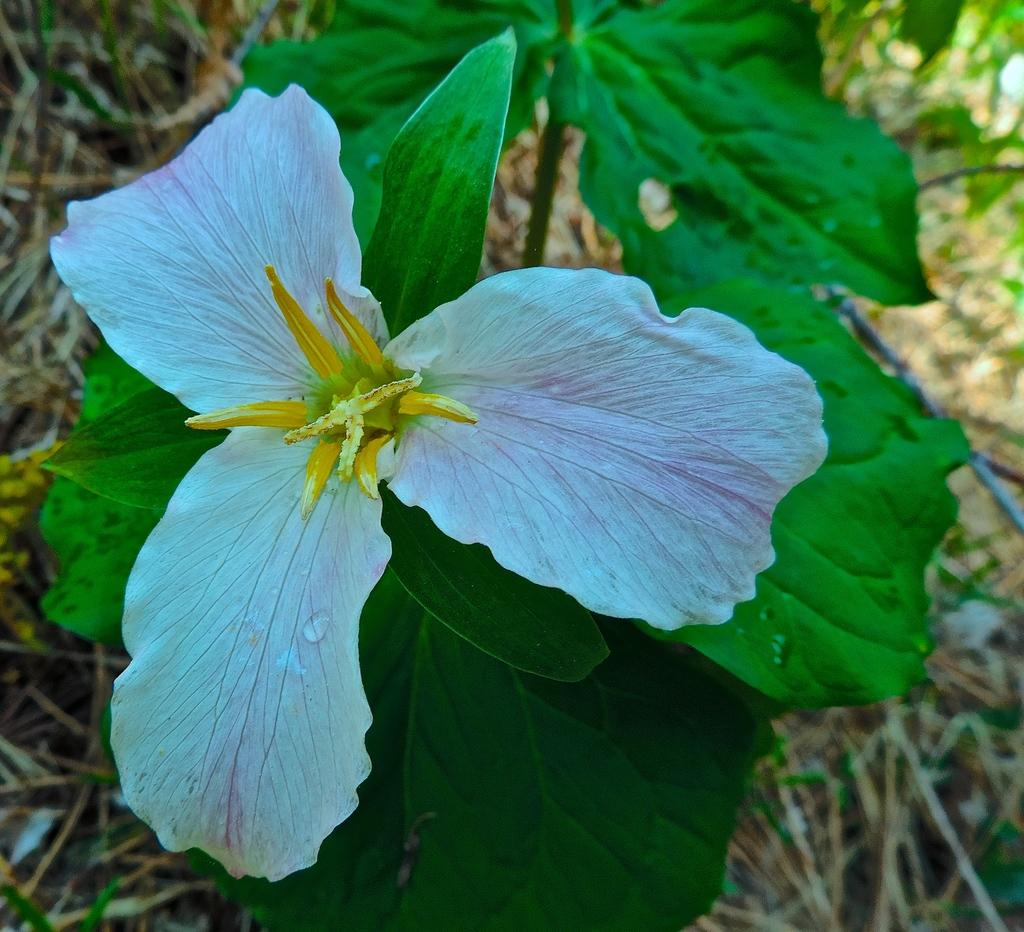What type of plant is visible in the image? There is a flower on a plant in the image. What type of vegetation is at the bottom of the image? There is grass at the bottom of the image. What is the surface visible in the image? There is ground visible in the image. What type of coach can be seen in the image? There is no coach present in the image. What is the whip used for in the image? There is no whip present in the image. 